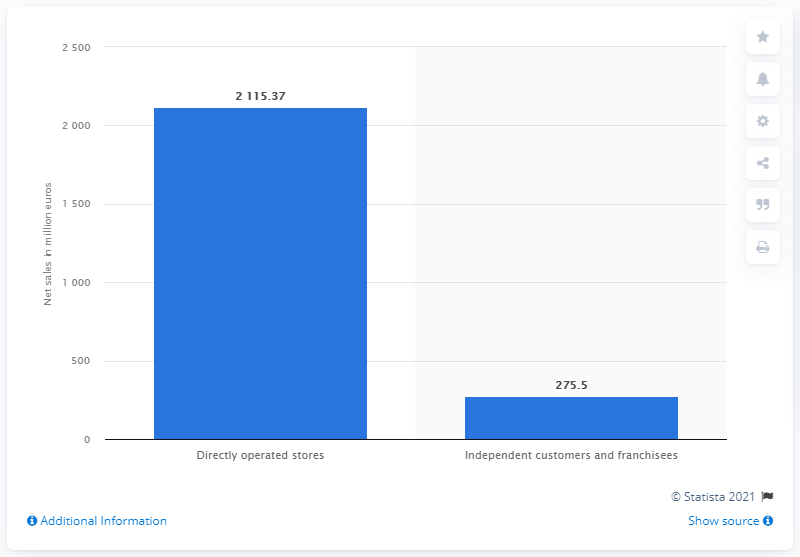Draw attention to some important aspects in this diagram. In 2020, the net sales from Prada's stores were 2115.37. 